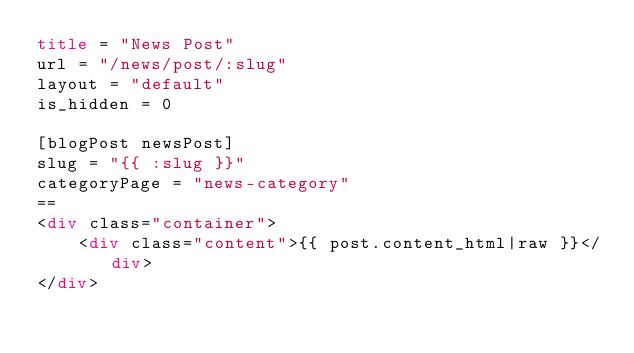Convert code to text. <code><loc_0><loc_0><loc_500><loc_500><_HTML_>title = "News Post"
url = "/news/post/:slug"
layout = "default"
is_hidden = 0

[blogPost newsPost]
slug = "{{ :slug }}"
categoryPage = "news-category"
==
<div class="container">
    <div class="content">{{ post.content_html|raw }}</div>
</div></code> 